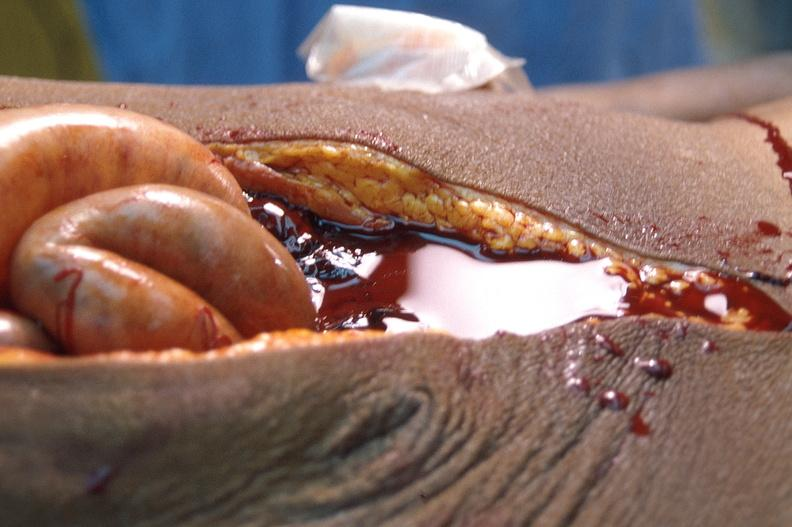does this image show ascites?
Answer the question using a single word or phrase. Yes 